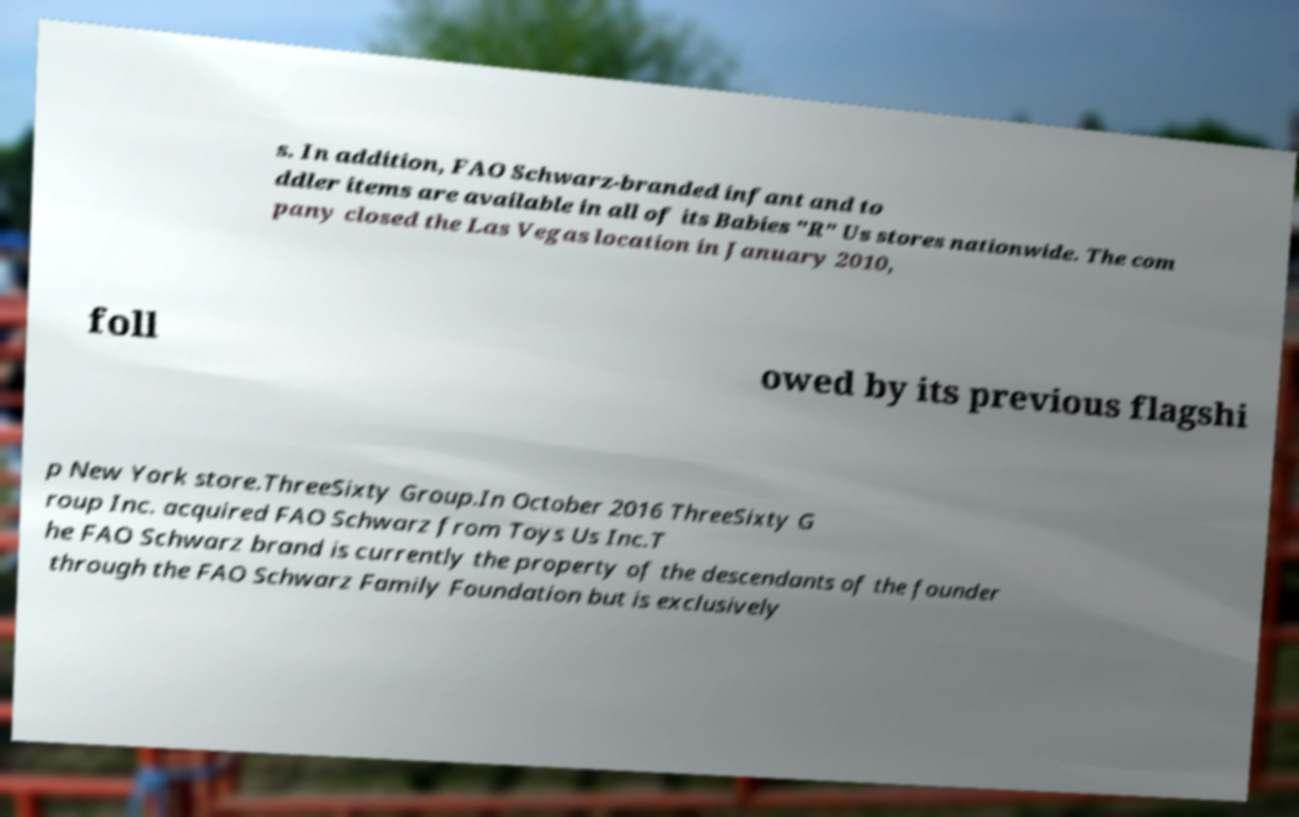Can you read and provide the text displayed in the image?This photo seems to have some interesting text. Can you extract and type it out for me? s. In addition, FAO Schwarz-branded infant and to ddler items are available in all of its Babies "R" Us stores nationwide. The com pany closed the Las Vegas location in January 2010, foll owed by its previous flagshi p New York store.ThreeSixty Group.In October 2016 ThreeSixty G roup Inc. acquired FAO Schwarz from Toys Us Inc.T he FAO Schwarz brand is currently the property of the descendants of the founder through the FAO Schwarz Family Foundation but is exclusively 